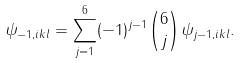Convert formula to latex. <formula><loc_0><loc_0><loc_500><loc_500>\psi _ { - 1 , i k l } = \sum _ { j = 1 } ^ { 6 } ( - 1 ) ^ { j - 1 } \binom { 6 } { j } \psi _ { j - 1 , i k l } .</formula> 